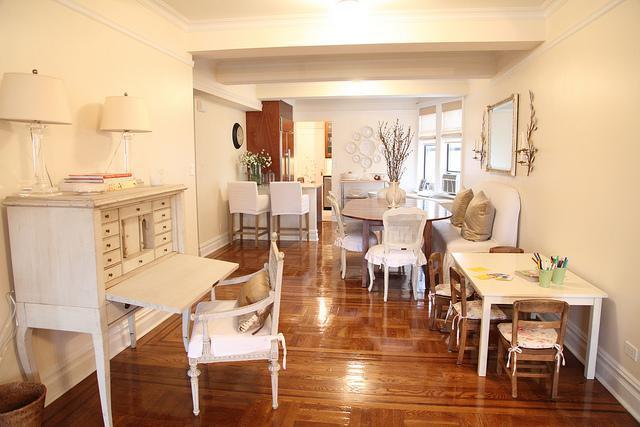How many chairs are there?
Give a very brief answer. 6. How many people are wearing glasses?
Give a very brief answer. 0. 